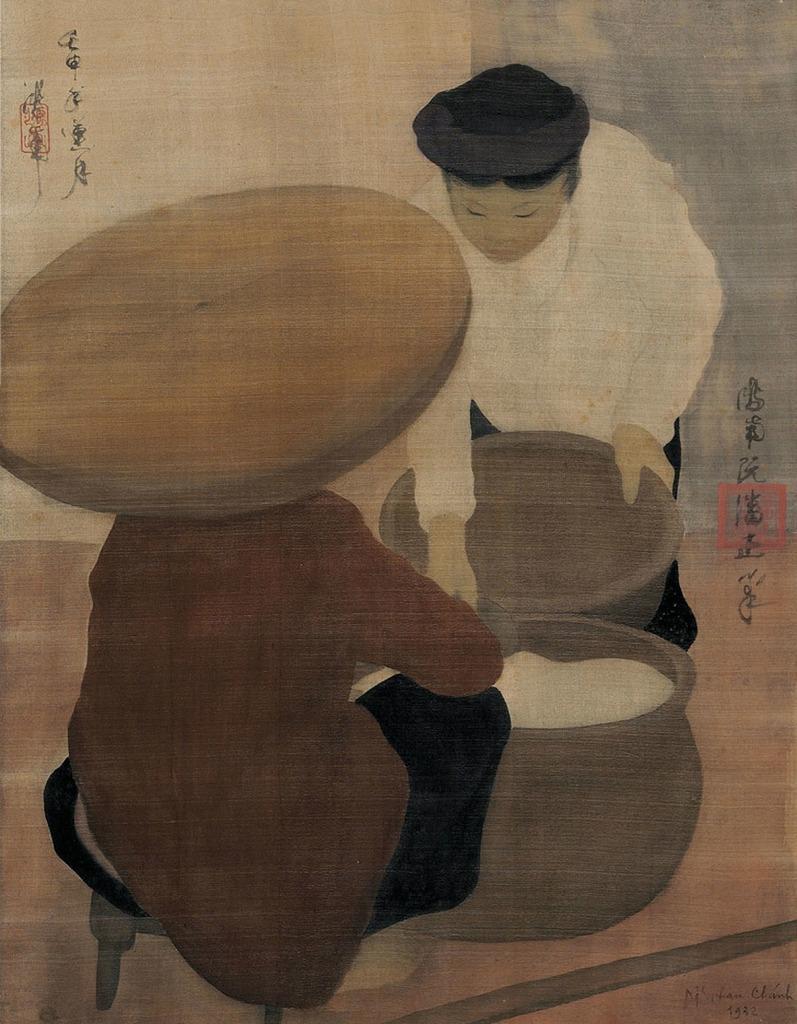Please provide a concise description of this image. This picture contains the painting of two men. The man in the brown blazer is sitting on the stool. In front of him, we see a bowl containing white color thing. Beside that, the man in the white shirt is holding a bowl in his hand. In the background, it is in blue and white color. 